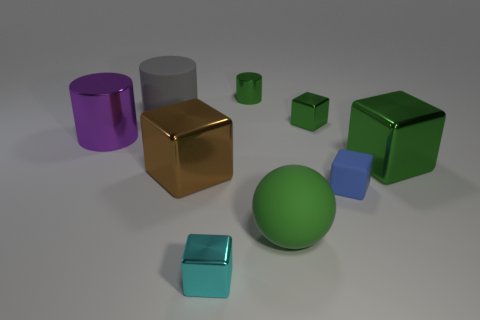Subtract all brown blocks. How many blocks are left? 4 Subtract all small blue matte cubes. How many cubes are left? 4 Subtract all gray cubes. Subtract all blue balls. How many cubes are left? 5 Add 1 large cylinders. How many objects exist? 10 Subtract all balls. How many objects are left? 8 Subtract all big green shiny cubes. Subtract all large purple things. How many objects are left? 7 Add 7 large metal things. How many large metal things are left? 10 Add 2 tiny blue matte things. How many tiny blue matte things exist? 3 Subtract 0 red cylinders. How many objects are left? 9 